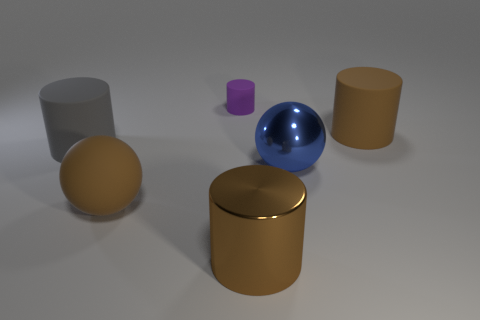Add 1 large brown cylinders. How many objects exist? 7 Subtract all cylinders. How many objects are left? 2 Add 5 tiny gray blocks. How many tiny gray blocks exist? 5 Subtract 0 yellow balls. How many objects are left? 6 Subtract all gray rubber things. Subtract all purple cylinders. How many objects are left? 4 Add 4 brown shiny cylinders. How many brown shiny cylinders are left? 5 